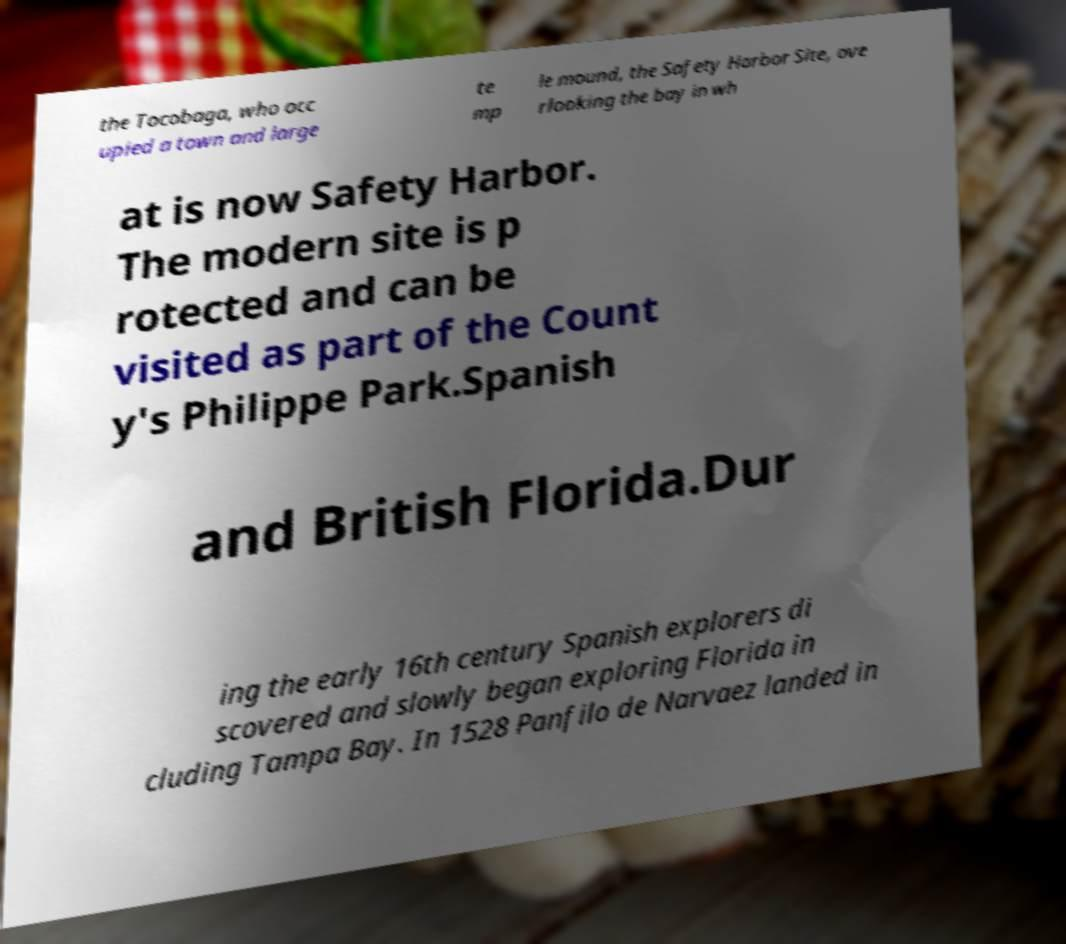For documentation purposes, I need the text within this image transcribed. Could you provide that? the Tocobaga, who occ upied a town and large te mp le mound, the Safety Harbor Site, ove rlooking the bay in wh at is now Safety Harbor. The modern site is p rotected and can be visited as part of the Count y's Philippe Park.Spanish and British Florida.Dur ing the early 16th century Spanish explorers di scovered and slowly began exploring Florida in cluding Tampa Bay. In 1528 Panfilo de Narvaez landed in 